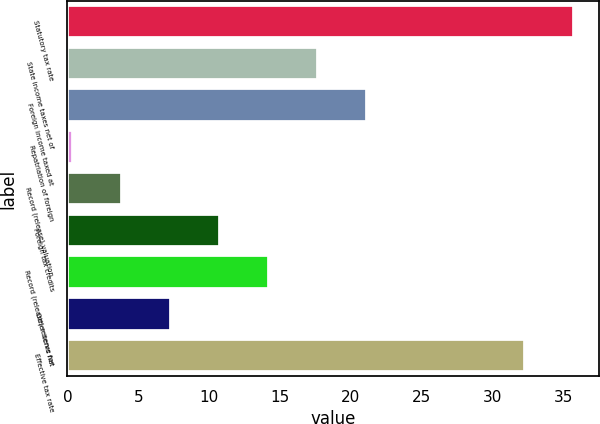Convert chart to OTSL. <chart><loc_0><loc_0><loc_500><loc_500><bar_chart><fcel>Statutory tax rate<fcel>State income taxes net of<fcel>Foreign income taxed at<fcel>Repatriation of foreign<fcel>Record (release) valuation<fcel>Foreign tax credits<fcel>Record (release) reserve for<fcel>Other items net<fcel>Effective tax rate<nl><fcel>35.76<fcel>17.7<fcel>21.16<fcel>0.4<fcel>3.86<fcel>10.78<fcel>14.24<fcel>7.32<fcel>32.3<nl></chart> 